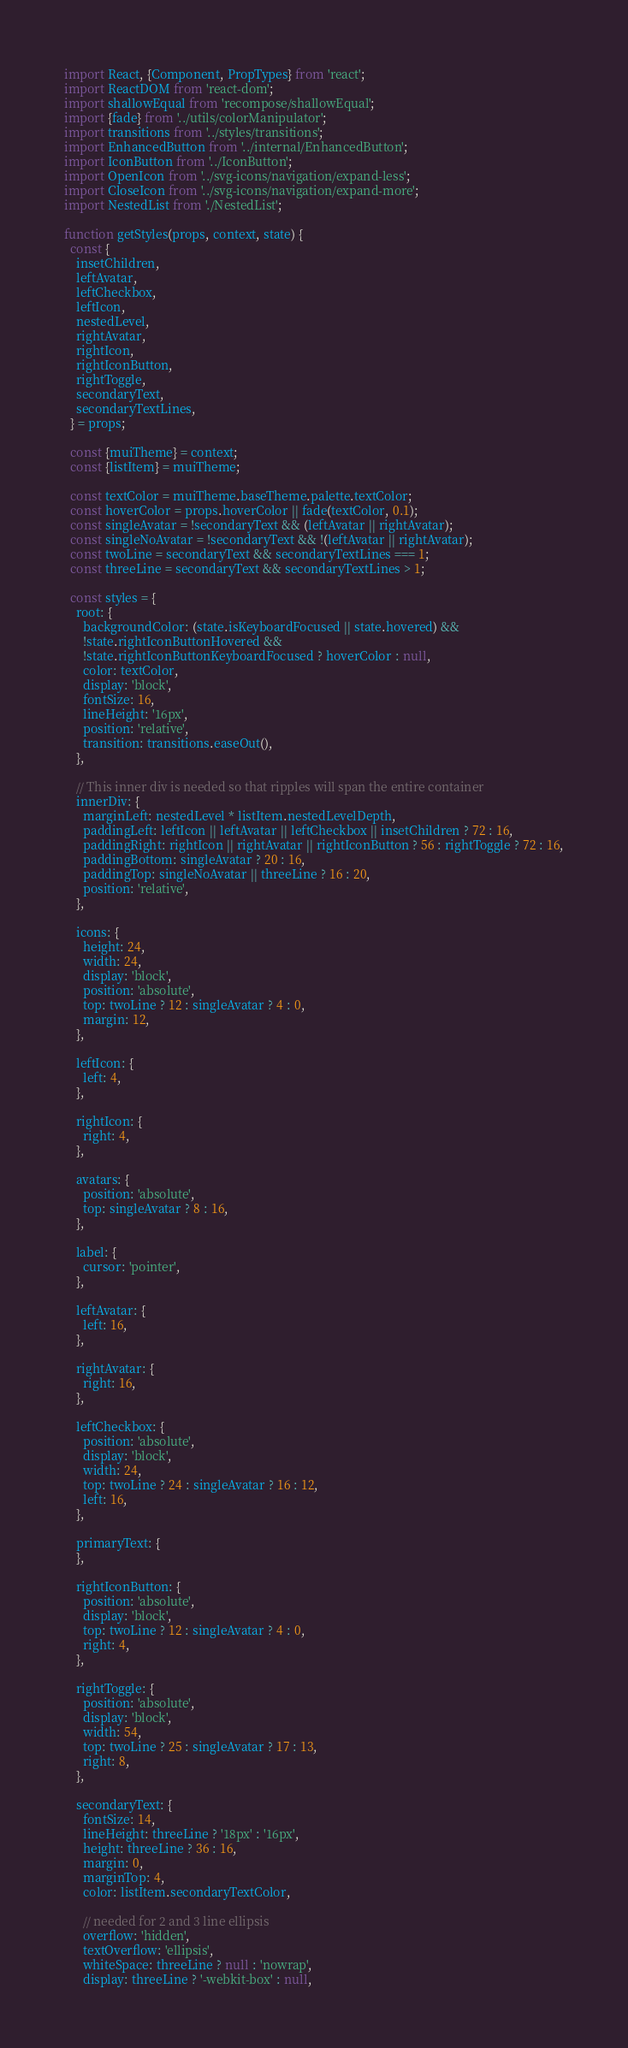Convert code to text. <code><loc_0><loc_0><loc_500><loc_500><_JavaScript_>import React, {Component, PropTypes} from 'react';
import ReactDOM from 'react-dom';
import shallowEqual from 'recompose/shallowEqual';
import {fade} from '../utils/colorManipulator';
import transitions from '../styles/transitions';
import EnhancedButton from '../internal/EnhancedButton';
import IconButton from '../IconButton';
import OpenIcon from '../svg-icons/navigation/expand-less';
import CloseIcon from '../svg-icons/navigation/expand-more';
import NestedList from './NestedList';

function getStyles(props, context, state) {
  const {
    insetChildren,
    leftAvatar,
    leftCheckbox,
    leftIcon,
    nestedLevel,
    rightAvatar,
    rightIcon,
    rightIconButton,
    rightToggle,
    secondaryText,
    secondaryTextLines,
  } = props;

  const {muiTheme} = context;
  const {listItem} = muiTheme;

  const textColor = muiTheme.baseTheme.palette.textColor;
  const hoverColor = props.hoverColor || fade(textColor, 0.1);
  const singleAvatar = !secondaryText && (leftAvatar || rightAvatar);
  const singleNoAvatar = !secondaryText && !(leftAvatar || rightAvatar);
  const twoLine = secondaryText && secondaryTextLines === 1;
  const threeLine = secondaryText && secondaryTextLines > 1;

  const styles = {
    root: {
      backgroundColor: (state.isKeyboardFocused || state.hovered) &&
      !state.rightIconButtonHovered &&
      !state.rightIconButtonKeyboardFocused ? hoverColor : null,
      color: textColor,
      display: 'block',
      fontSize: 16,
      lineHeight: '16px',
      position: 'relative',
      transition: transitions.easeOut(),
    },

    // This inner div is needed so that ripples will span the entire container
    innerDiv: {
      marginLeft: nestedLevel * listItem.nestedLevelDepth,
      paddingLeft: leftIcon || leftAvatar || leftCheckbox || insetChildren ? 72 : 16,
      paddingRight: rightIcon || rightAvatar || rightIconButton ? 56 : rightToggle ? 72 : 16,
      paddingBottom: singleAvatar ? 20 : 16,
      paddingTop: singleNoAvatar || threeLine ? 16 : 20,
      position: 'relative',
    },

    icons: {
      height: 24,
      width: 24,
      display: 'block',
      position: 'absolute',
      top: twoLine ? 12 : singleAvatar ? 4 : 0,
      margin: 12,
    },

    leftIcon: {
      left: 4,
    },

    rightIcon: {
      right: 4,
    },

    avatars: {
      position: 'absolute',
      top: singleAvatar ? 8 : 16,
    },

    label: {
      cursor: 'pointer',
    },

    leftAvatar: {
      left: 16,
    },

    rightAvatar: {
      right: 16,
    },

    leftCheckbox: {
      position: 'absolute',
      display: 'block',
      width: 24,
      top: twoLine ? 24 : singleAvatar ? 16 : 12,
      left: 16,
    },

    primaryText: {
    },

    rightIconButton: {
      position: 'absolute',
      display: 'block',
      top: twoLine ? 12 : singleAvatar ? 4 : 0,
      right: 4,
    },

    rightToggle: {
      position: 'absolute',
      display: 'block',
      width: 54,
      top: twoLine ? 25 : singleAvatar ? 17 : 13,
      right: 8,
    },

    secondaryText: {
      fontSize: 14,
      lineHeight: threeLine ? '18px' : '16px',
      height: threeLine ? 36 : 16,
      margin: 0,
      marginTop: 4,
      color: listItem.secondaryTextColor,

      // needed for 2 and 3 line ellipsis
      overflow: 'hidden',
      textOverflow: 'ellipsis',
      whiteSpace: threeLine ? null : 'nowrap',
      display: threeLine ? '-webkit-box' : null,</code> 